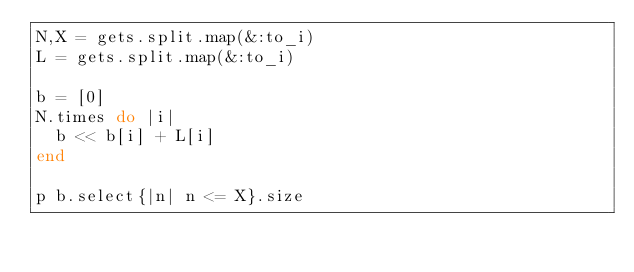Convert code to text. <code><loc_0><loc_0><loc_500><loc_500><_Ruby_>N,X = gets.split.map(&:to_i)
L = gets.split.map(&:to_i)

b = [0]
N.times do |i|
  b << b[i] + L[i]
end

p b.select{|n| n <= X}.size</code> 